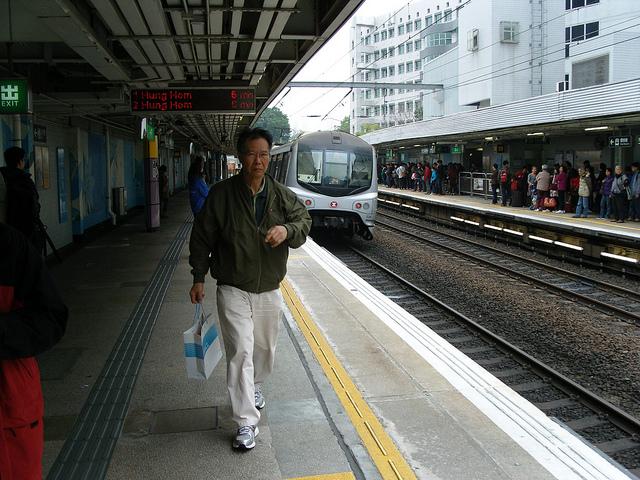Does the man have anything in his hands?
Be succinct. Yes. Is the man walking fast?
Concise answer only. No. What color is the stripe on the bag?
Be succinct. Blue. 